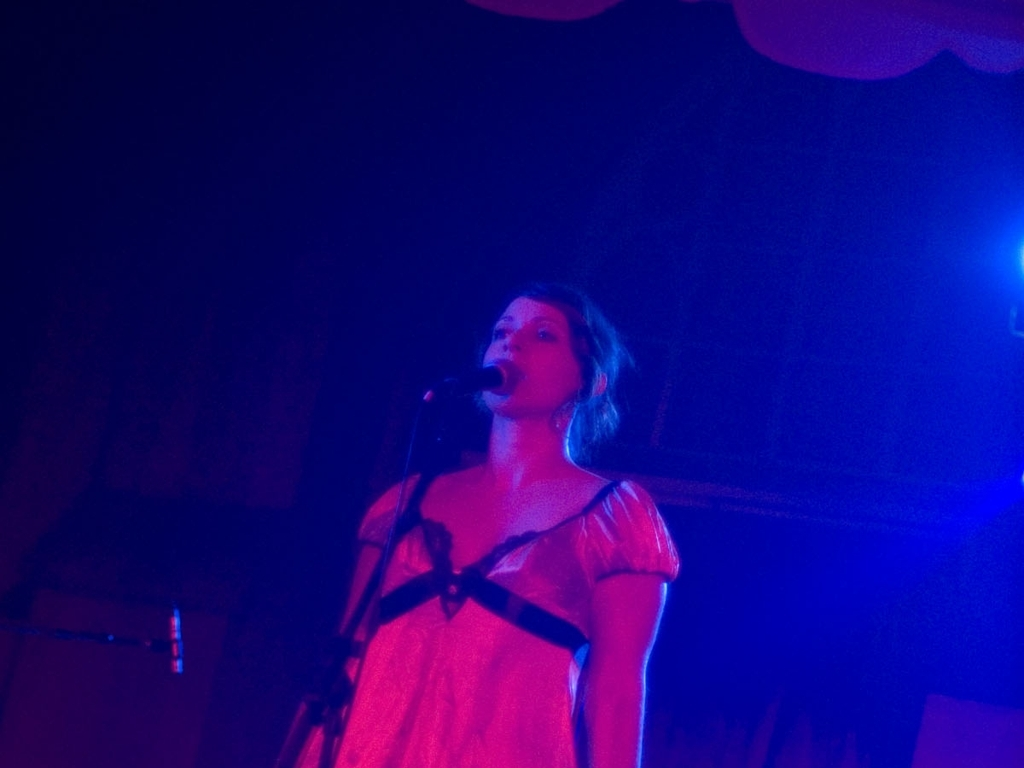Are there any quality issues with this image? The image appears to have a reddish hue which may be due to the lighting conditions during the photo capture, and it is slightly underexposed, making details difficult to discern. The focus also seems to be soft, lacking sharpness on the subject. 